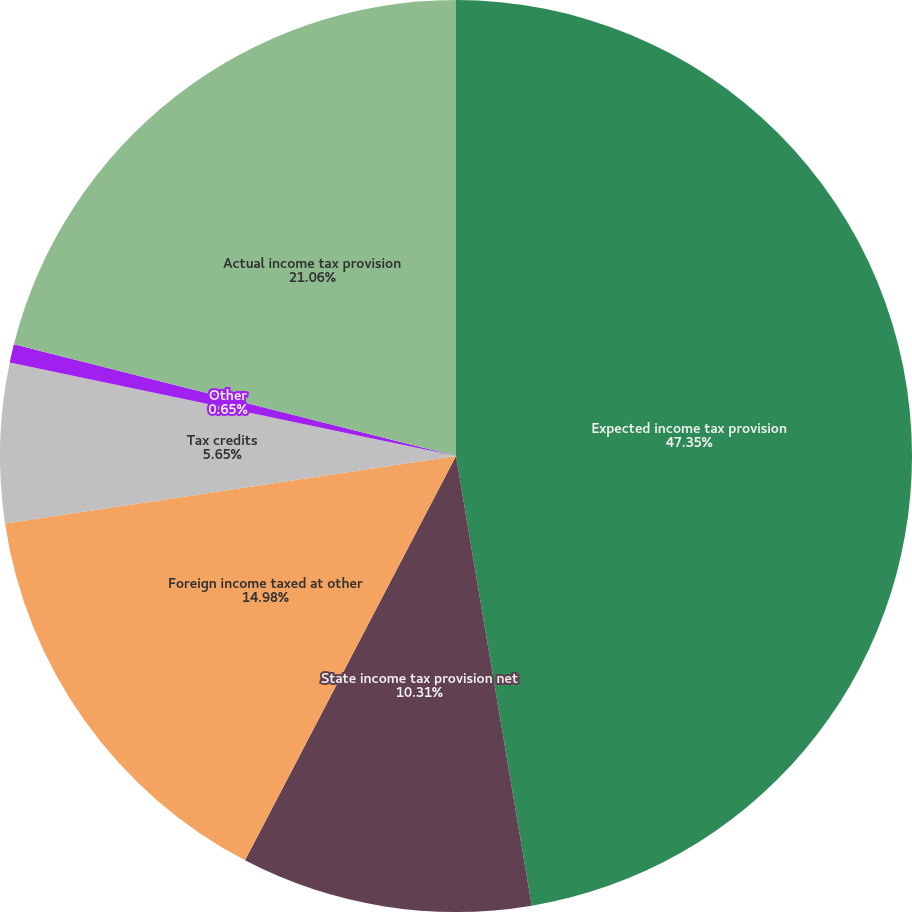Convert chart to OTSL. <chart><loc_0><loc_0><loc_500><loc_500><pie_chart><fcel>Expected income tax provision<fcel>State income tax provision net<fcel>Foreign income taxed at other<fcel>Tax credits<fcel>Other<fcel>Actual income tax provision<nl><fcel>47.34%<fcel>10.31%<fcel>14.98%<fcel>5.65%<fcel>0.65%<fcel>21.06%<nl></chart> 